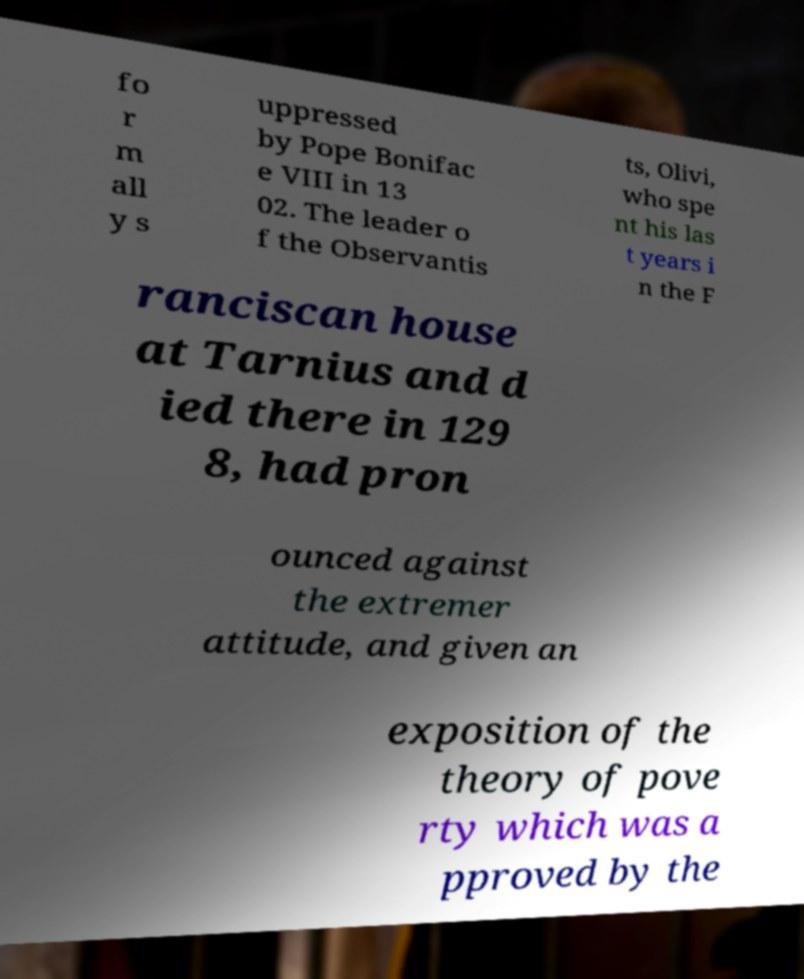Can you read and provide the text displayed in the image?This photo seems to have some interesting text. Can you extract and type it out for me? fo r m all y s uppressed by Pope Bonifac e VIII in 13 02. The leader o f the Observantis ts, Olivi, who spe nt his las t years i n the F ranciscan house at Tarnius and d ied there in 129 8, had pron ounced against the extremer attitude, and given an exposition of the theory of pove rty which was a pproved by the 